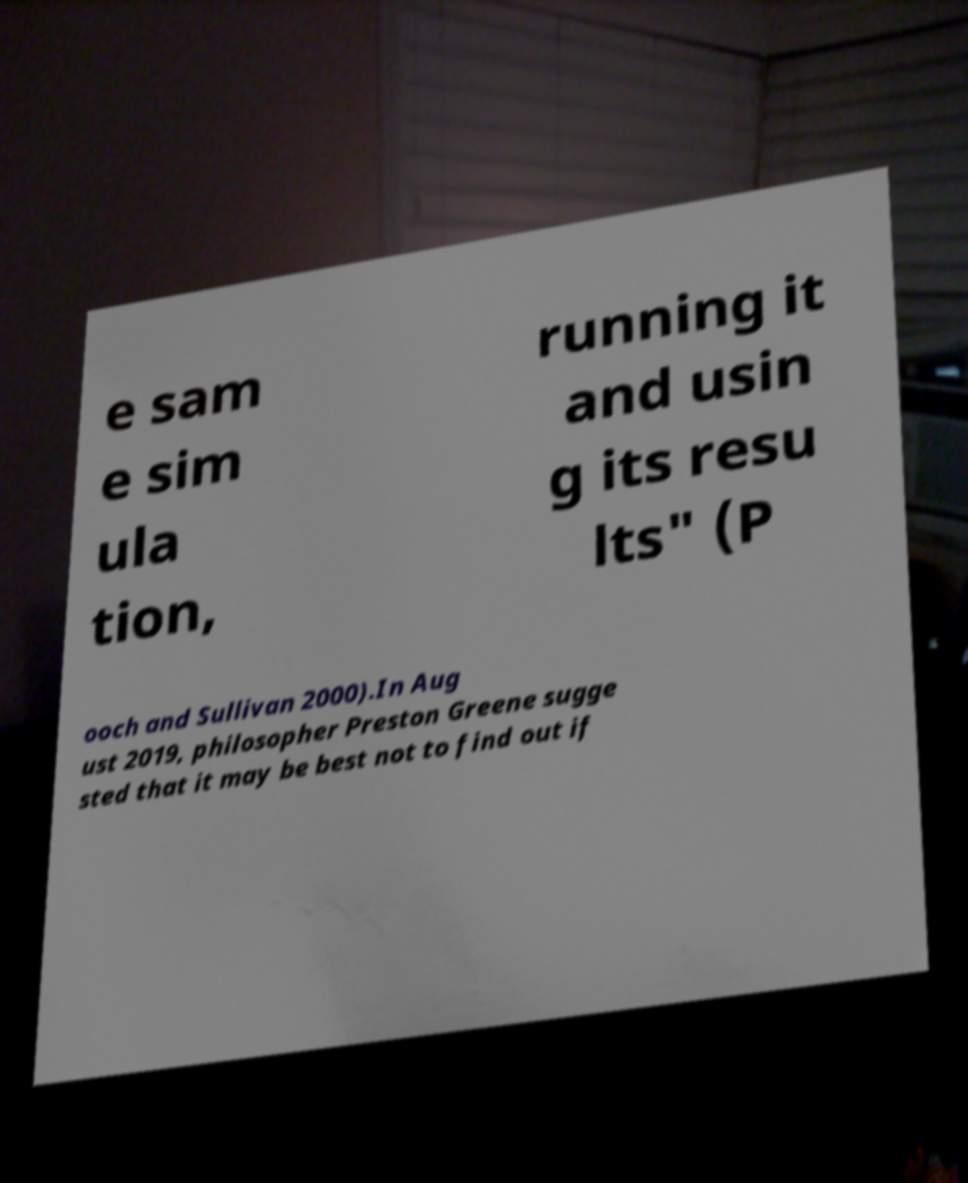Please identify and transcribe the text found in this image. e sam e sim ula tion, running it and usin g its resu lts" (P ooch and Sullivan 2000).In Aug ust 2019, philosopher Preston Greene sugge sted that it may be best not to find out if 